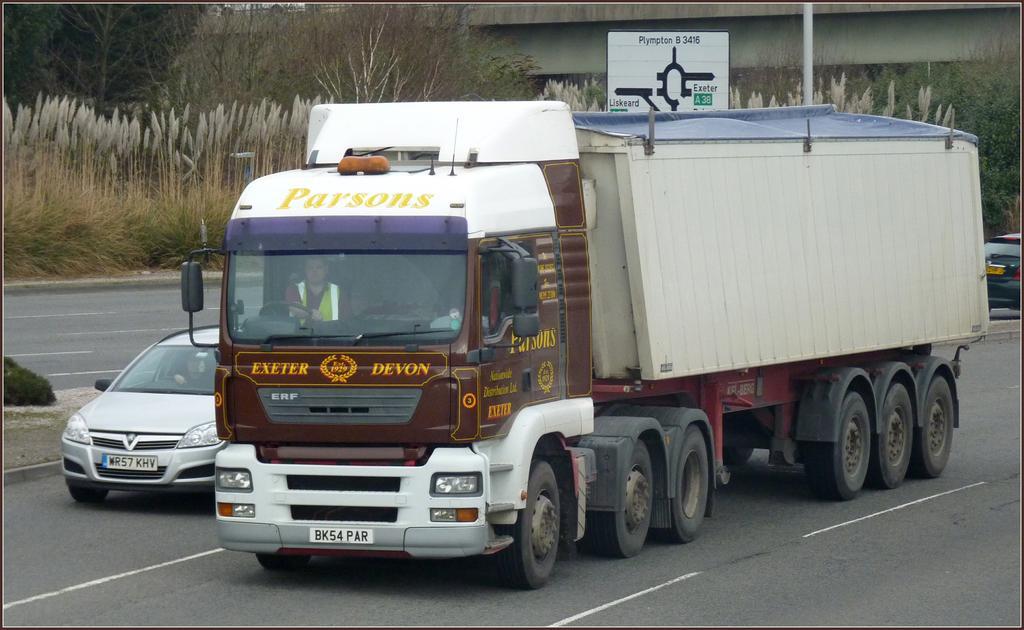Could you give a brief overview of what you see in this image? In the picture we can see a road on it, we can see a truck with many tires and beside the truck we can see a car which is gray in color and behind it, we can see grass plants, plants and trees and in the background we can see a part of the bridge and some pole near it. 